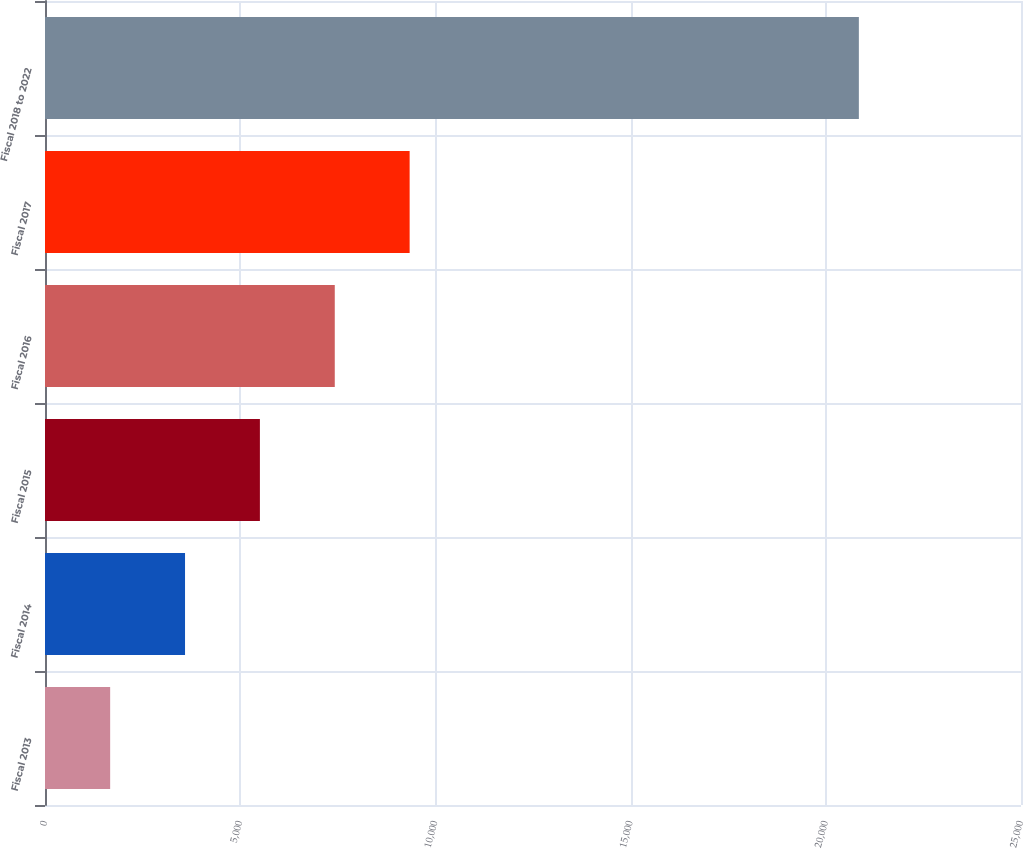Convert chart. <chart><loc_0><loc_0><loc_500><loc_500><bar_chart><fcel>Fiscal 2013<fcel>Fiscal 2014<fcel>Fiscal 2015<fcel>Fiscal 2016<fcel>Fiscal 2017<fcel>Fiscal 2018 to 2022<nl><fcel>1669<fcel>3586.8<fcel>5504.6<fcel>7422.4<fcel>9340.2<fcel>20847<nl></chart> 